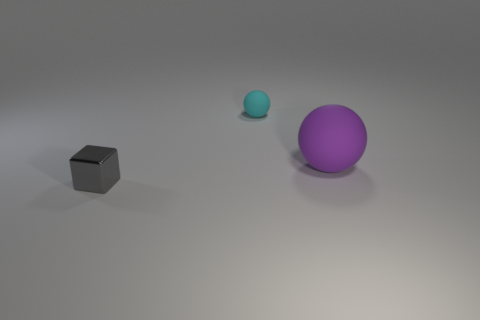Is there anything else that has the same material as the tiny block?
Make the answer very short. No. Do the tiny rubber object and the large purple thing have the same shape?
Provide a succinct answer. Yes. What color is the sphere that is the same material as the large object?
Offer a very short reply. Cyan. How many objects are either tiny things that are in front of the cyan ball or large purple metallic objects?
Your answer should be very brief. 1. What size is the thing that is right of the cyan object?
Your answer should be very brief. Large. There is a cyan matte thing; does it have the same size as the object that is in front of the large purple rubber object?
Your answer should be very brief. Yes. What color is the rubber sphere on the right side of the sphere behind the large purple matte sphere?
Your response must be concise. Purple. The gray object is what size?
Offer a terse response. Small. Are there more small things in front of the purple sphere than large balls in front of the tiny gray metallic block?
Ensure brevity in your answer.  Yes. There is a rubber ball behind the large matte thing; how many tiny cubes are behind it?
Offer a very short reply. 0. 